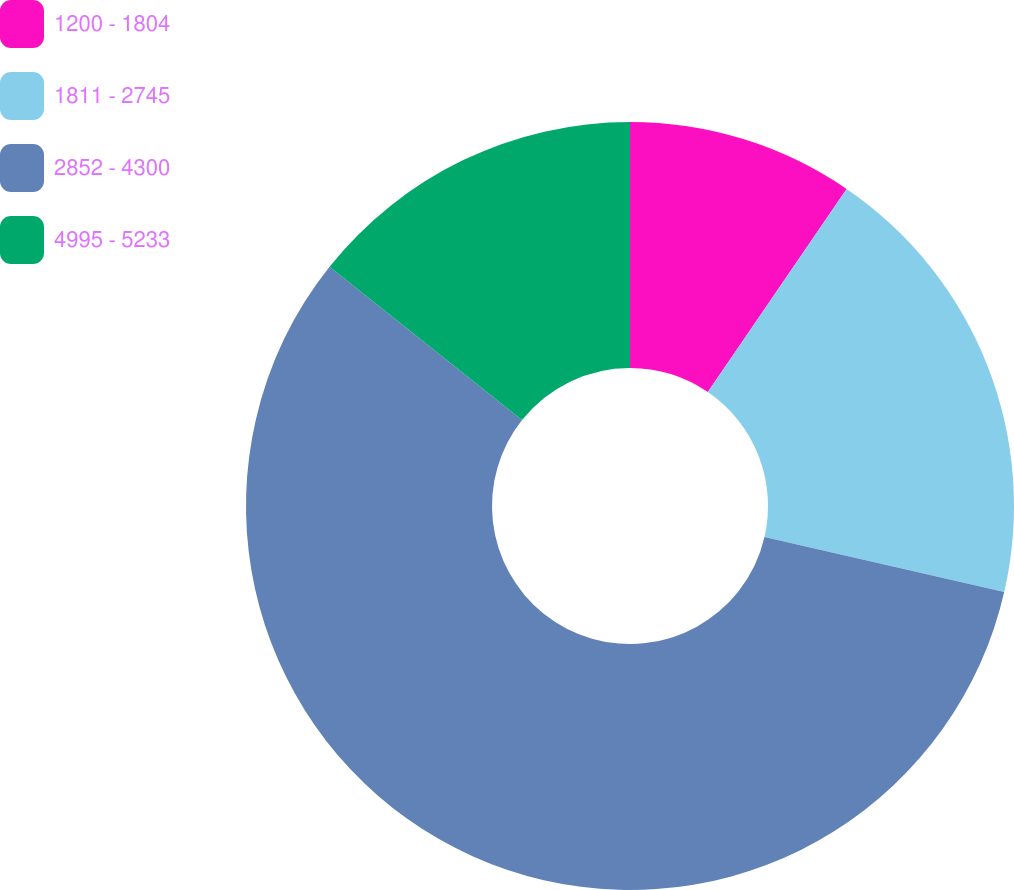Convert chart. <chart><loc_0><loc_0><loc_500><loc_500><pie_chart><fcel>1200 - 1804<fcel>1811 - 2745<fcel>2852 - 4300<fcel>4995 - 5233<nl><fcel>9.54%<fcel>19.06%<fcel>57.1%<fcel>14.3%<nl></chart> 